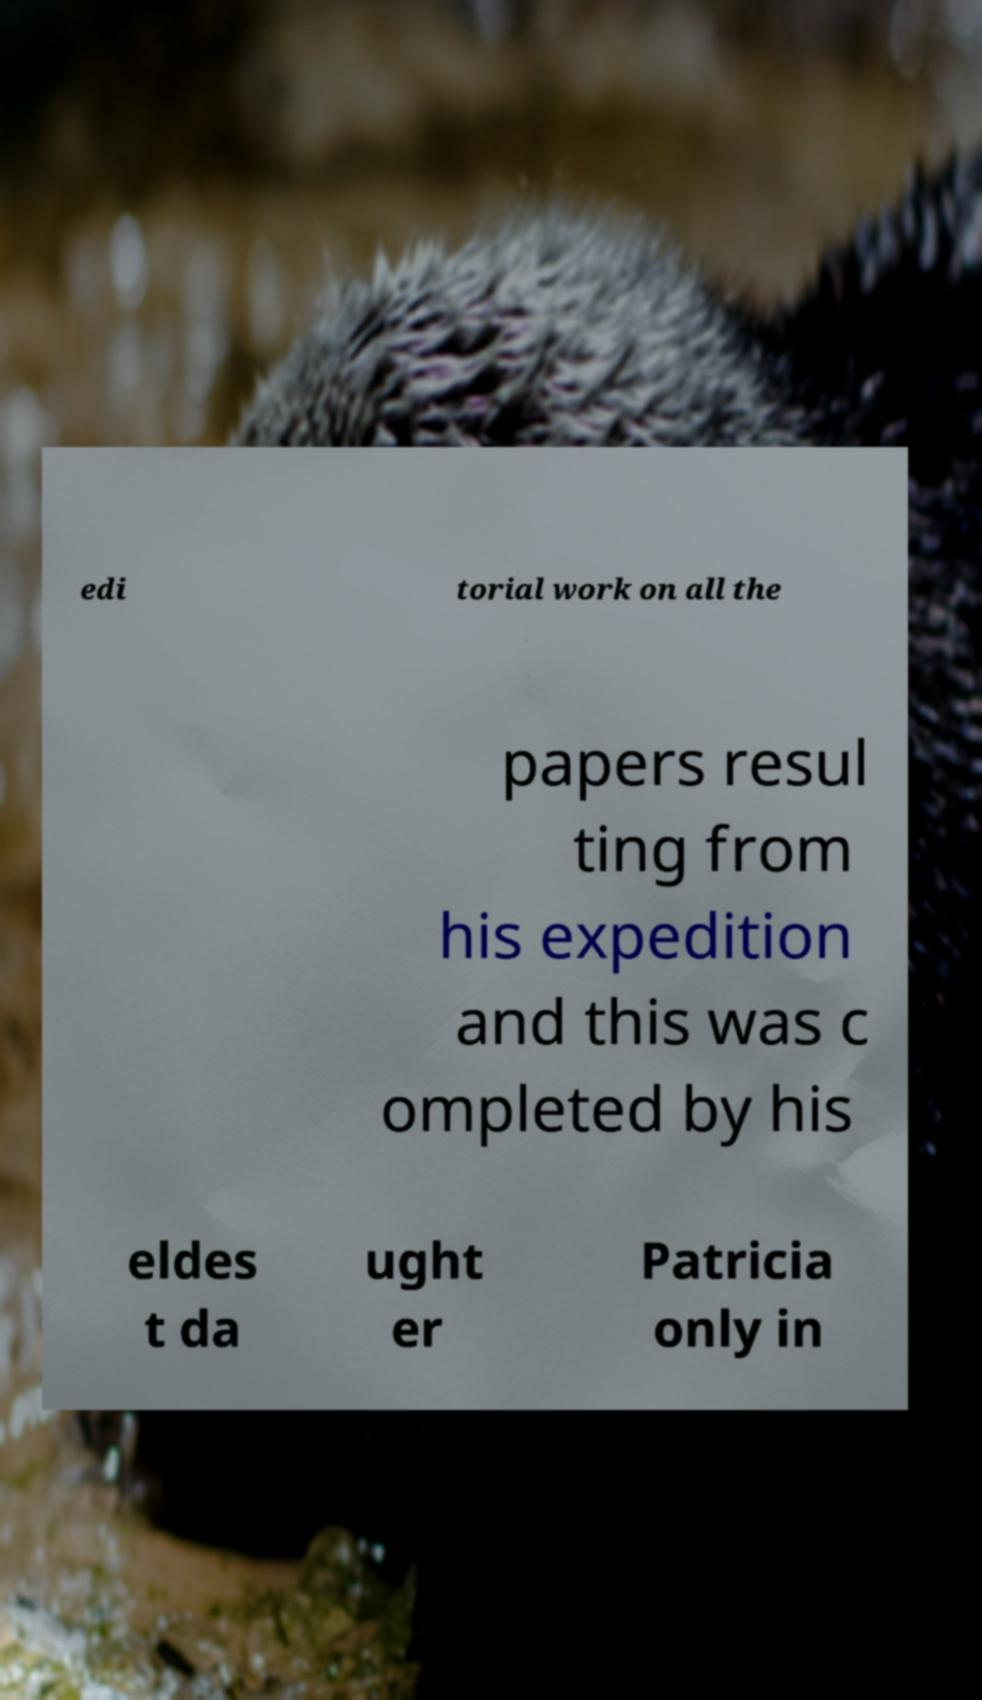Can you accurately transcribe the text from the provided image for me? edi torial work on all the papers resul ting from his expedition and this was c ompleted by his eldes t da ught er Patricia only in 